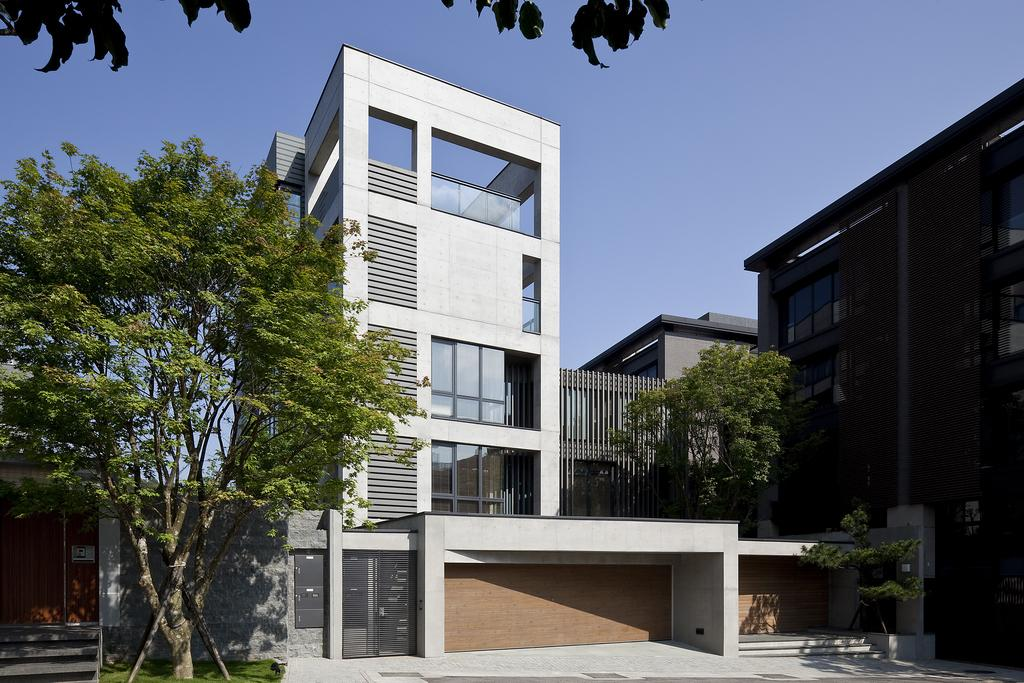What type of structures can be seen in the image? There are buildings in the image. What other natural elements are present in the image? There are trees in the image. What is visible at the top of the image? The sky is visible at the top of the image. What might be used for entry or exit in the image? There are gates in the image. What type of pickle is hanging from the trees in the image? There are no pickles present in the image; it features buildings, trees, and gates. Can you tell me how many brushes are visible in the image? There are no brushes present in the image. 